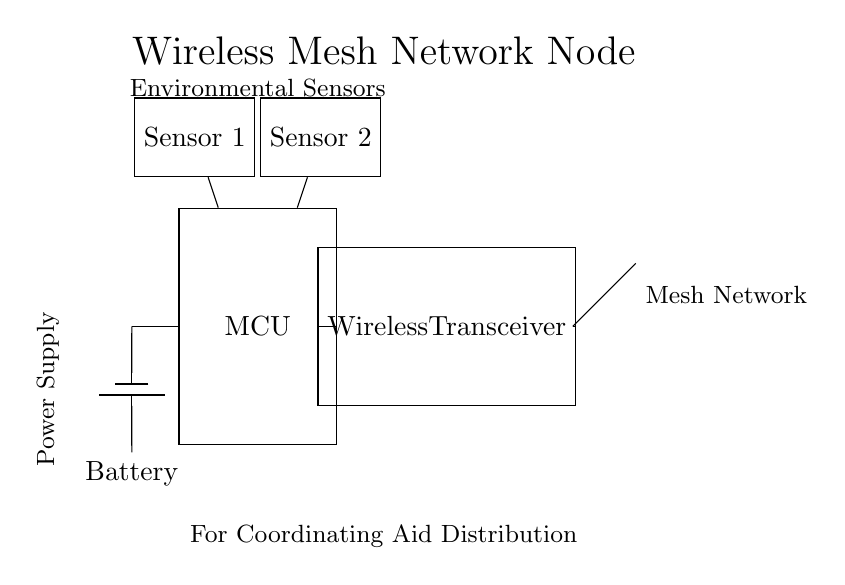What component is responsible for communication in this circuit? The Wireless Transceiver is labeled as such in the circuit diagram and it facilitates communication between nodes in the mesh network.
Answer: Wireless Transceiver What type of sensors are indicated in the circuit? The circuit diagram indicates two Environmental Sensors. These are labeled as Sensor 1 and Sensor 2 in the diagram, which suggests their function in monitoring environmental conditions.
Answer: Environmental Sensors How many sensors are connected to the main control unit? The circuit diagram shows two sensors, Sensor 1 and Sensor 2, connected to the main control unit (MCU). This is determined by tracing the connections from the MCU to each sensor.
Answer: Two What type of power source is used in this device? The circuit includes a Battery component, which is depicted in the circuit as providing power to the system. Its specific type (battery1) indicates a standard battery component.
Answer: Battery What is the purpose of the antenna in this circuit? The Antenna is used to facilitate wireless communication in the mesh network. Its presence indicates that the system is designed to connect over the air rather than through wired connections.
Answer: Wireless communication Which component connects to both the battery and environmental sensors? The Main Control Unit (MCU) connects to both the Battery and the Environmental Sensors, indicating its role in managing power and sensor data within the circuit.
Answer: Main Control Unit How does the wireless transceiver connect in the system? The Wireless Transceiver has connections from the Main Control Unit and to the antenna, establishing its role in sending and receiving signals within the mesh network.
Answer: By connections to MCU and antenna 